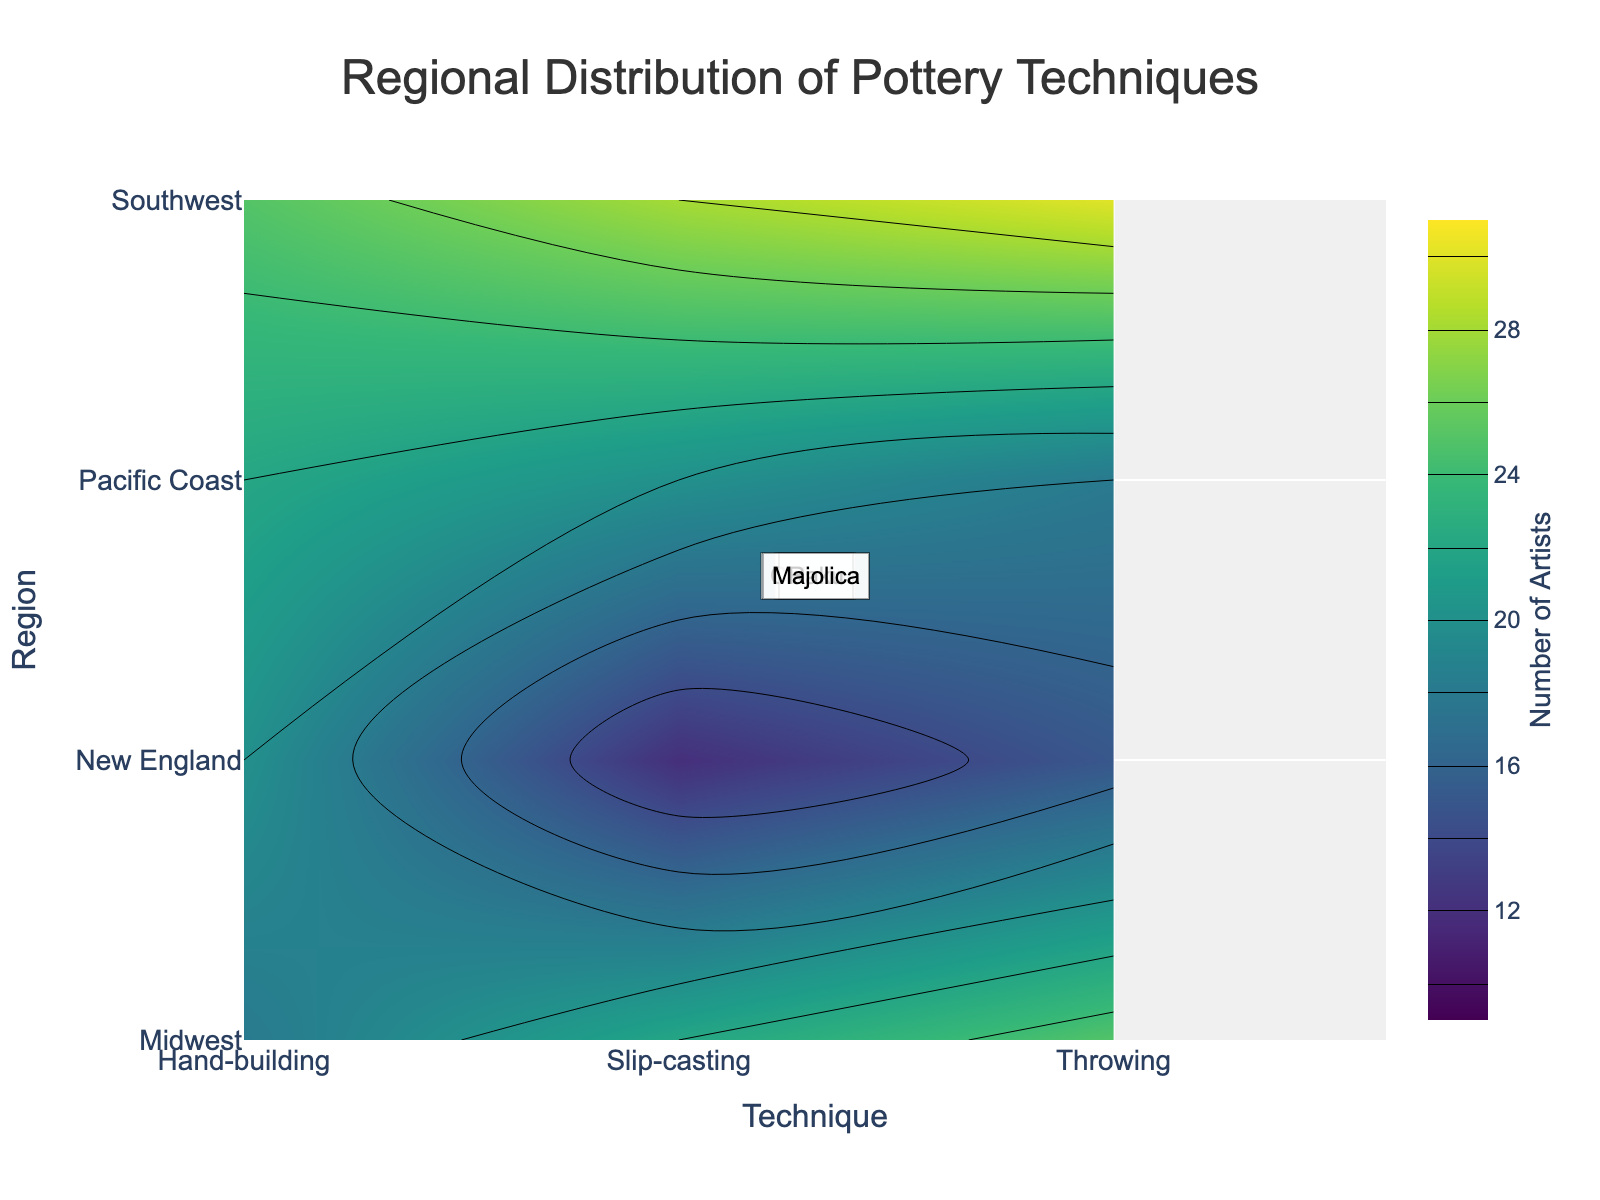What is the title of the plot? The title of the plot is located at the top center and it reads "Regional Distribution of Pottery Techniques."
Answer: Regional Distribution of Pottery Techniques Which region has the most artists using the throwing technique? Look at the contour plot and identify the region with the darkest color for the throwing technique category along the x-axis. The Midwest region has the highest number of artists using the throwing technique, with a count of 25.
Answer: Midwest What is the range of the color scale for the number of artists? The color scale is displayed on the right side of the plot. It ranges from 10 (lightest color) to 30 (darkest color).
Answer: 10-30 How many artists use hand-building techniques in the New England region? Find the New England region along the y-axis and then move horizontally to the hand-building technique. The contour color should indicate around 20 artists.
Answer: 20 Compare the number of artists practicing slip-casting in the Midwest and Pacific Coast regions. Which has more? Check the contour colors for slip-casting in both the Midwest and Pacific Coast regions. The Midwest region has a count of 22, while the Pacific Coast has a count of 20. Therefore, the Midwest has slightly more.
Answer: Midwest What is the total number of artists using any technique in the Southwest region? Add the number of artists for all techniques in the Southwest region: 30 (throwing) + 25 (hand-building) + 28 (slip-casting) = 83 artists.
Answer: 83 What technique has the least number of artists in New England, and how many are there? Look at the contour plot for New England and identify the lightest color corresponding to a technique. Slip-casting has the least number with 12 artists.
Answer: Slip-casting, 12 Which region has the second highest number of artists using the Majolica style with any technique? Find the regions using the Majolica style and compare their counts. The Pacific Coast is the only region that uses Majolica, with counts 18 (throwing), 22 (hand-building), and 20 (slip-casting). The middle value in the sorted data would be 20, indicating the second highest number is 22 for hand-building in the Pacific Coast region.
Answer: Pacific Coast In which region and technique combination do we find exactly 28 artists? Check the contour plot for a contour level indicating 28 artists. Southwest region with slip-casting technique has exactly 28 artists.
Answer: Southwest, Slip-casting 